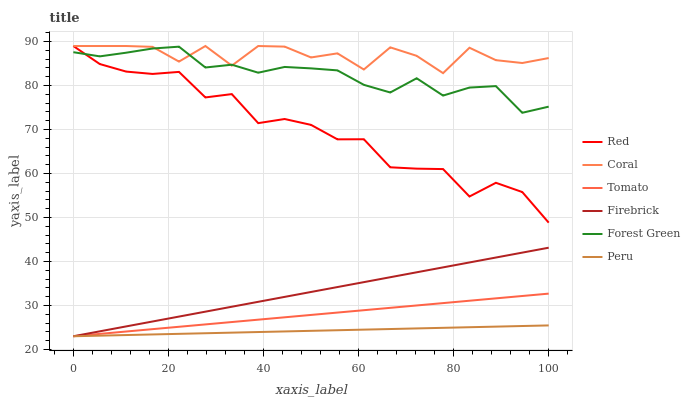Does Forest Green have the minimum area under the curve?
Answer yes or no. No. Does Forest Green have the maximum area under the curve?
Answer yes or no. No. Is Forest Green the smoothest?
Answer yes or no. No. Is Forest Green the roughest?
Answer yes or no. No. Does Forest Green have the lowest value?
Answer yes or no. No. Does Forest Green have the highest value?
Answer yes or no. No. Is Peru less than Red?
Answer yes or no. Yes. Is Coral greater than Firebrick?
Answer yes or no. Yes. Does Peru intersect Red?
Answer yes or no. No. 